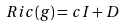<formula> <loc_0><loc_0><loc_500><loc_500>R i c ( g ) = c I + D</formula> 